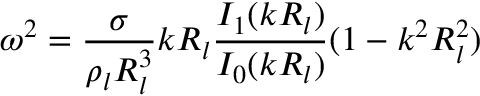Convert formula to latex. <formula><loc_0><loc_0><loc_500><loc_500>\omega ^ { 2 } = \frac { \sigma } { \rho _ { l } R _ { l } ^ { 3 } } k R _ { l } \frac { I _ { 1 } ( k R _ { l } ) } { I _ { 0 } ( k R _ { l } ) } ( 1 - k ^ { 2 } R _ { l } ^ { 2 } )</formula> 